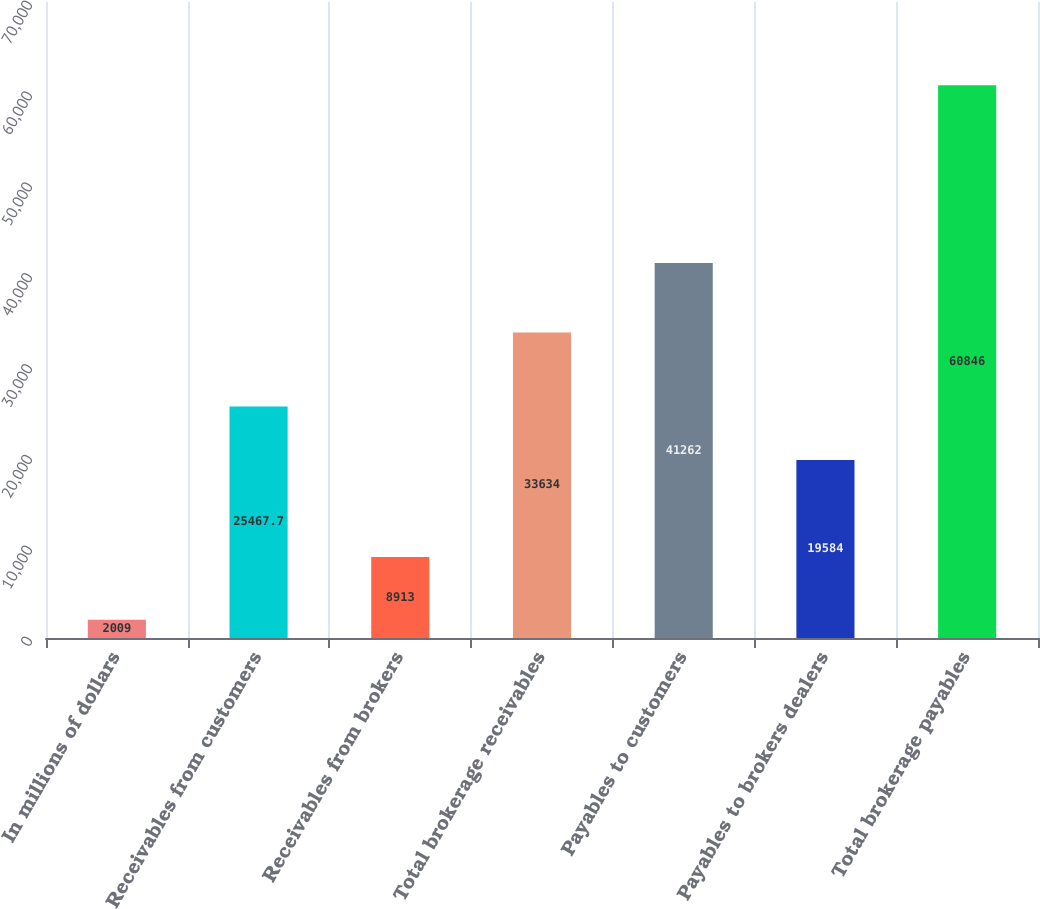<chart> <loc_0><loc_0><loc_500><loc_500><bar_chart><fcel>In millions of dollars<fcel>Receivables from customers<fcel>Receivables from brokers<fcel>Total brokerage receivables<fcel>Payables to customers<fcel>Payables to brokers dealers<fcel>Total brokerage payables<nl><fcel>2009<fcel>25467.7<fcel>8913<fcel>33634<fcel>41262<fcel>19584<fcel>60846<nl></chart> 